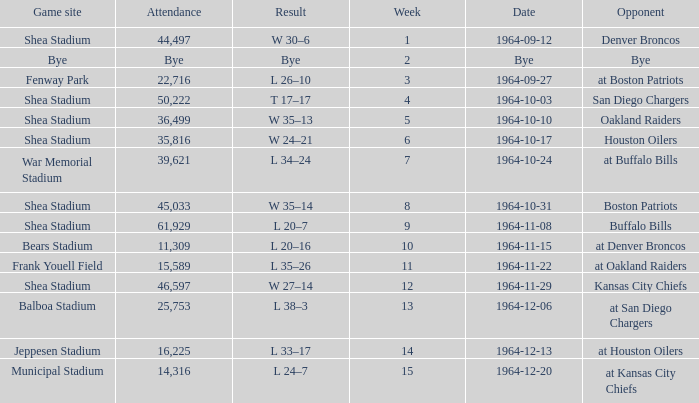What's the consequence of the game against bye? Bye. 